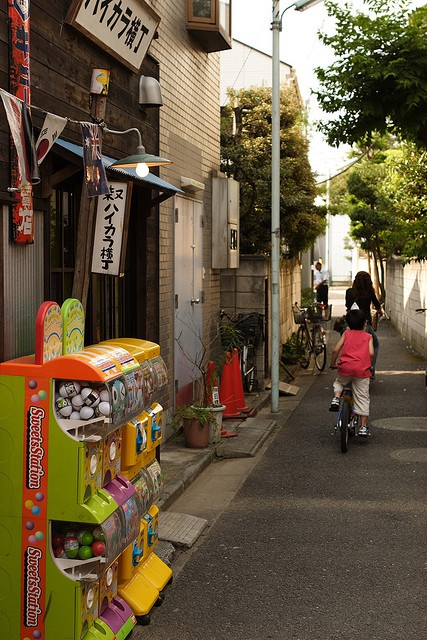Describe the objects in this image and their specific colors. I can see potted plant in black, gray, and maroon tones, people in black, brown, and maroon tones, bicycle in black, gray, and maroon tones, potted plant in black, maroon, darkgreen, and gray tones, and people in black, ivory, maroon, and olive tones in this image. 